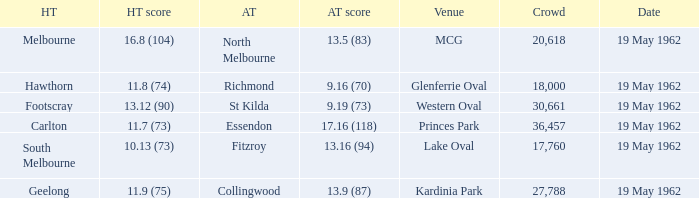What day is the venue the western oval? 19 May 1962. 